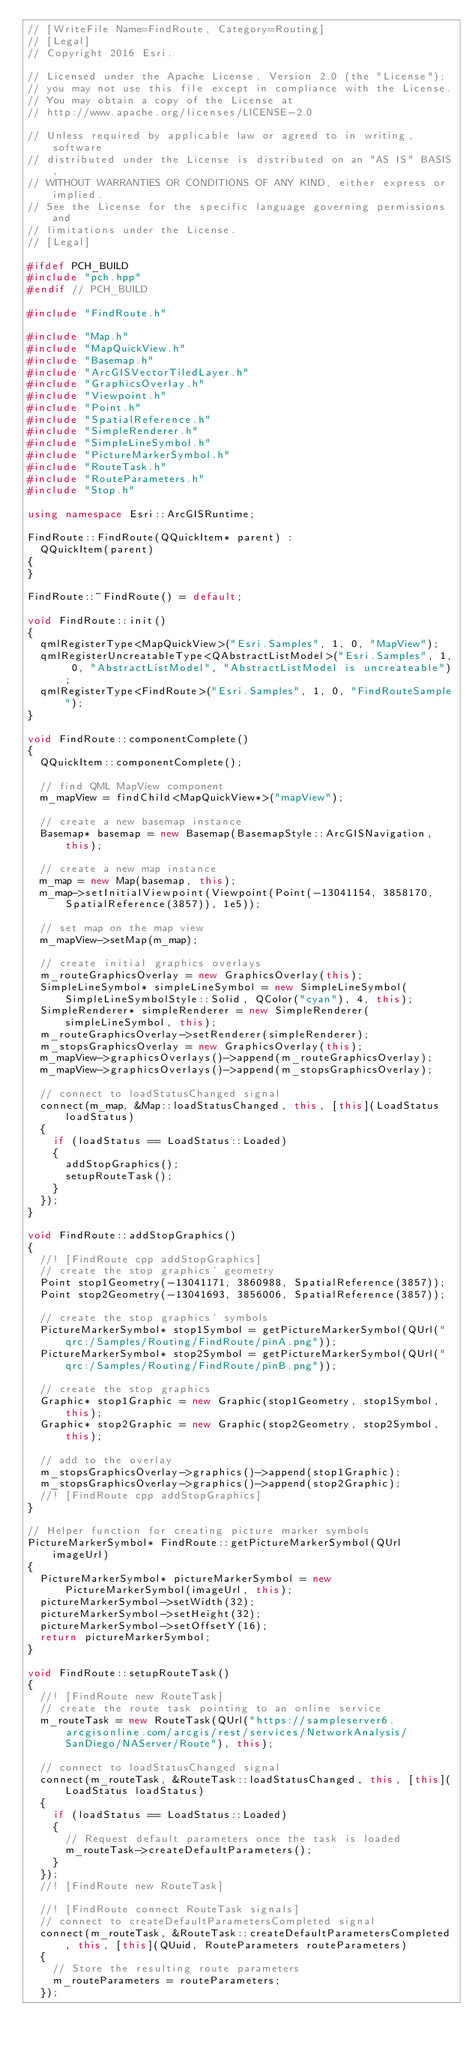Convert code to text. <code><loc_0><loc_0><loc_500><loc_500><_C++_>// [WriteFile Name=FindRoute, Category=Routing]
// [Legal]
// Copyright 2016 Esri.

// Licensed under the Apache License, Version 2.0 (the "License");
// you may not use this file except in compliance with the License.
// You may obtain a copy of the License at
// http://www.apache.org/licenses/LICENSE-2.0

// Unless required by applicable law or agreed to in writing, software
// distributed under the License is distributed on an "AS IS" BASIS,
// WITHOUT WARRANTIES OR CONDITIONS OF ANY KIND, either express or implied.
// See the License for the specific language governing permissions and
// limitations under the License.
// [Legal]

#ifdef PCH_BUILD
#include "pch.hpp"
#endif // PCH_BUILD

#include "FindRoute.h"

#include "Map.h"
#include "MapQuickView.h"
#include "Basemap.h"
#include "ArcGISVectorTiledLayer.h"
#include "GraphicsOverlay.h"
#include "Viewpoint.h"
#include "Point.h"
#include "SpatialReference.h"
#include "SimpleRenderer.h"
#include "SimpleLineSymbol.h"
#include "PictureMarkerSymbol.h"
#include "RouteTask.h"
#include "RouteParameters.h"
#include "Stop.h"

using namespace Esri::ArcGISRuntime;

FindRoute::FindRoute(QQuickItem* parent) :
  QQuickItem(parent)
{
}

FindRoute::~FindRoute() = default;

void FindRoute::init()
{
  qmlRegisterType<MapQuickView>("Esri.Samples", 1, 0, "MapView");
  qmlRegisterUncreatableType<QAbstractListModel>("Esri.Samples", 1, 0, "AbstractListModel", "AbstractListModel is uncreateable");
  qmlRegisterType<FindRoute>("Esri.Samples", 1, 0, "FindRouteSample");
}

void FindRoute::componentComplete()
{
  QQuickItem::componentComplete();

  // find QML MapView component
  m_mapView = findChild<MapQuickView*>("mapView");

  // create a new basemap instance
  Basemap* basemap = new Basemap(BasemapStyle::ArcGISNavigation, this);

  // create a new map instance
  m_map = new Map(basemap, this);
  m_map->setInitialViewpoint(Viewpoint(Point(-13041154, 3858170, SpatialReference(3857)), 1e5));

  // set map on the map view
  m_mapView->setMap(m_map);

  // create initial graphics overlays
  m_routeGraphicsOverlay = new GraphicsOverlay(this);
  SimpleLineSymbol* simpleLineSymbol = new SimpleLineSymbol(SimpleLineSymbolStyle::Solid, QColor("cyan"), 4, this);
  SimpleRenderer* simpleRenderer = new SimpleRenderer(simpleLineSymbol, this);
  m_routeGraphicsOverlay->setRenderer(simpleRenderer);
  m_stopsGraphicsOverlay = new GraphicsOverlay(this);
  m_mapView->graphicsOverlays()->append(m_routeGraphicsOverlay);
  m_mapView->graphicsOverlays()->append(m_stopsGraphicsOverlay);

  // connect to loadStatusChanged signal
  connect(m_map, &Map::loadStatusChanged, this, [this](LoadStatus loadStatus)
  {
    if (loadStatus == LoadStatus::Loaded)
    {
      addStopGraphics();
      setupRouteTask();
    }
  });
}

void FindRoute::addStopGraphics()
{
  //! [FindRoute cpp addStopGraphics]
  // create the stop graphics' geometry
  Point stop1Geometry(-13041171, 3860988, SpatialReference(3857));
  Point stop2Geometry(-13041693, 3856006, SpatialReference(3857));

  // create the stop graphics' symbols
  PictureMarkerSymbol* stop1Symbol = getPictureMarkerSymbol(QUrl("qrc:/Samples/Routing/FindRoute/pinA.png"));
  PictureMarkerSymbol* stop2Symbol = getPictureMarkerSymbol(QUrl("qrc:/Samples/Routing/FindRoute/pinB.png"));

  // create the stop graphics
  Graphic* stop1Graphic = new Graphic(stop1Geometry, stop1Symbol, this);
  Graphic* stop2Graphic = new Graphic(stop2Geometry, stop2Symbol, this);

  // add to the overlay
  m_stopsGraphicsOverlay->graphics()->append(stop1Graphic);
  m_stopsGraphicsOverlay->graphics()->append(stop2Graphic);
  //! [FindRoute cpp addStopGraphics]
}

// Helper function for creating picture marker symbols
PictureMarkerSymbol* FindRoute::getPictureMarkerSymbol(QUrl imageUrl)
{
  PictureMarkerSymbol* pictureMarkerSymbol = new PictureMarkerSymbol(imageUrl, this);
  pictureMarkerSymbol->setWidth(32);
  pictureMarkerSymbol->setHeight(32);
  pictureMarkerSymbol->setOffsetY(16);
  return pictureMarkerSymbol;
}

void FindRoute::setupRouteTask()
{
  //! [FindRoute new RouteTask]
  // create the route task pointing to an online service
  m_routeTask = new RouteTask(QUrl("https://sampleserver6.arcgisonline.com/arcgis/rest/services/NetworkAnalysis/SanDiego/NAServer/Route"), this);

  // connect to loadStatusChanged signal
  connect(m_routeTask, &RouteTask::loadStatusChanged, this, [this](LoadStatus loadStatus)
  {
    if (loadStatus == LoadStatus::Loaded)
    {
      // Request default parameters once the task is loaded
      m_routeTask->createDefaultParameters();
    }
  });
  //! [FindRoute new RouteTask]

  //! [FindRoute connect RouteTask signals]
  // connect to createDefaultParametersCompleted signal
  connect(m_routeTask, &RouteTask::createDefaultParametersCompleted, this, [this](QUuid, RouteParameters routeParameters)
  {
    // Store the resulting route parameters
    m_routeParameters = routeParameters;
  });
</code> 